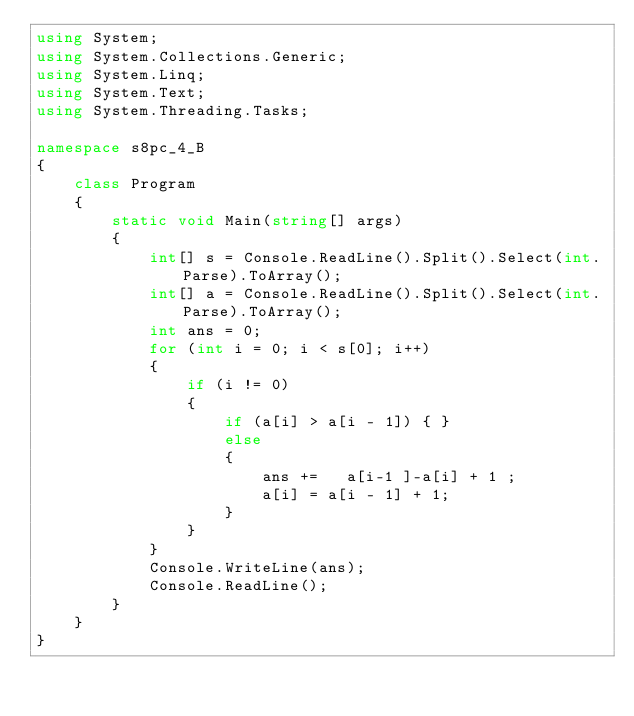<code> <loc_0><loc_0><loc_500><loc_500><_C#_>using System;
using System.Collections.Generic;
using System.Linq;
using System.Text;
using System.Threading.Tasks;

namespace s8pc_4_B
{
    class Program
    {
        static void Main(string[] args)
        {
            int[] s = Console.ReadLine().Split().Select(int.Parse).ToArray();
            int[] a = Console.ReadLine().Split().Select(int.Parse).ToArray();
            int ans = 0;
            for (int i = 0; i < s[0]; i++)
            {
                if (i != 0)
                {
                    if (a[i] > a[i - 1]) { }
                    else
                    {
                        ans +=   a[i-1 ]-a[i] + 1 ;
                        a[i] = a[i - 1] + 1;
                    }
                }
            }
            Console.WriteLine(ans);
            Console.ReadLine();
        }
    }
}
</code> 